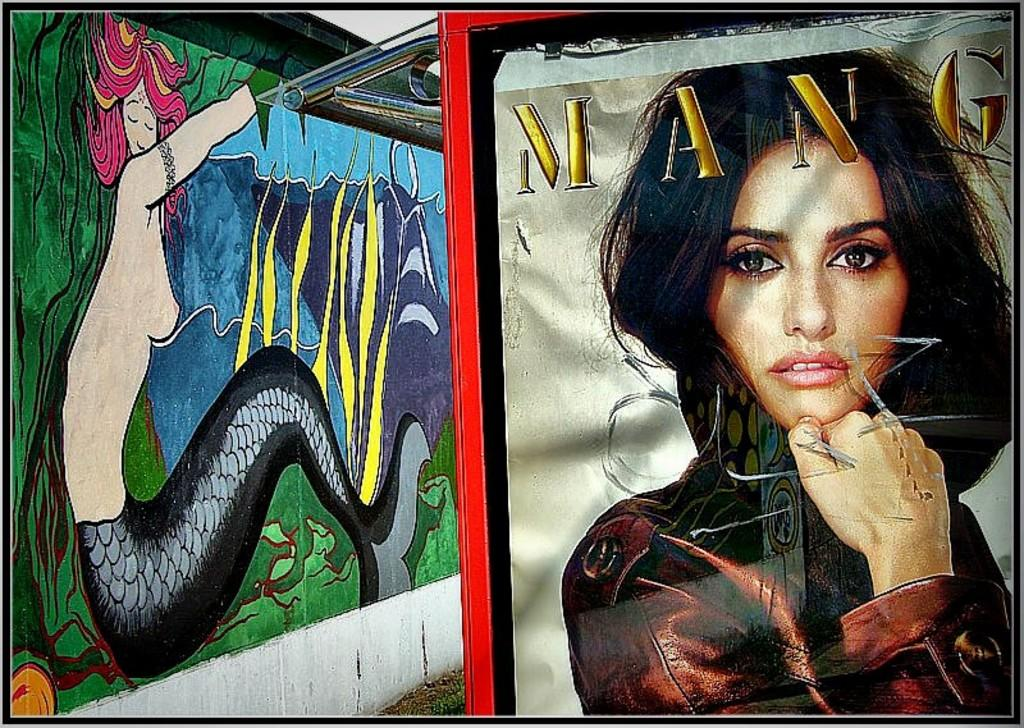What type of artwork is on the wall in the image? There is an art of a mermaid on the wall in the image. What else can be seen in the image besides the artwork? There is a picture of a woman in the image. What is the woman wearing in the image? The woman is wearing a brown dress in the image. Are there any words present in the image? Yes, there is a word written in the image. Can you see a rat running in the image? No, there is no rat or any running activity depicted in the image. What is the mass of the mermaid art on the wall? The mass of the mermaid art cannot be determined from the image alone, as it does not provide any information about the size or weight of the artwork. 